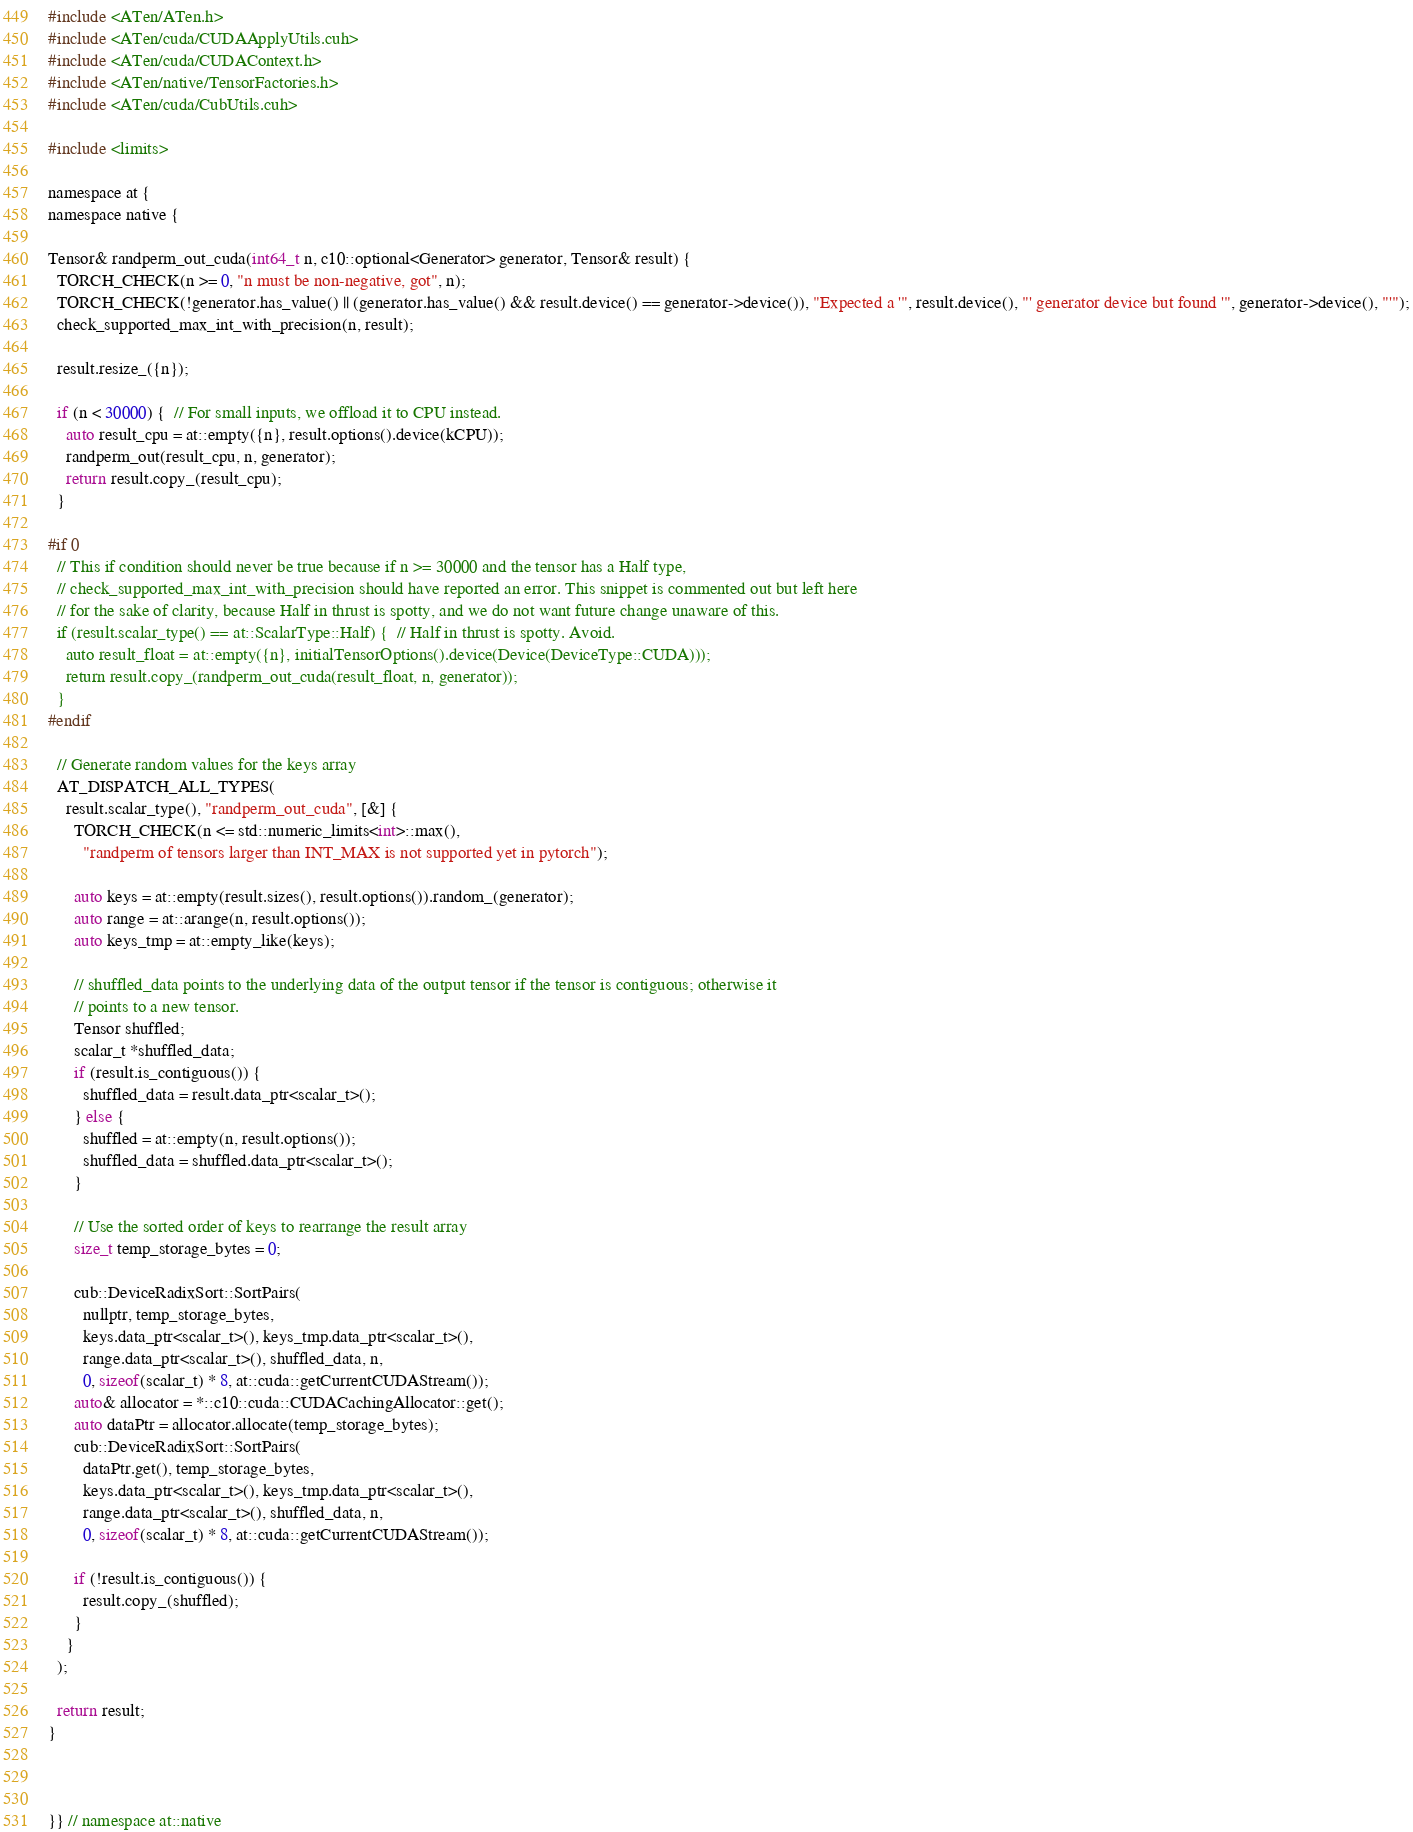<code> <loc_0><loc_0><loc_500><loc_500><_Cuda_>#include <ATen/ATen.h>
#include <ATen/cuda/CUDAApplyUtils.cuh>
#include <ATen/cuda/CUDAContext.h>
#include <ATen/native/TensorFactories.h>
#include <ATen/cuda/CubUtils.cuh>

#include <limits>

namespace at {
namespace native {

Tensor& randperm_out_cuda(int64_t n, c10::optional<Generator> generator, Tensor& result) {
  TORCH_CHECK(n >= 0, "n must be non-negative, got", n);
  TORCH_CHECK(!generator.has_value() || (generator.has_value() && result.device() == generator->device()), "Expected a '", result.device(), "' generator device but found '", generator->device(), "'");
  check_supported_max_int_with_precision(n, result);

  result.resize_({n});

  if (n < 30000) {  // For small inputs, we offload it to CPU instead.
    auto result_cpu = at::empty({n}, result.options().device(kCPU));
    randperm_out(result_cpu, n, generator);
    return result.copy_(result_cpu);
  }

#if 0
  // This if condition should never be true because if n >= 30000 and the tensor has a Half type,
  // check_supported_max_int_with_precision should have reported an error. This snippet is commented out but left here
  // for the sake of clarity, because Half in thrust is spotty, and we do not want future change unaware of this.
  if (result.scalar_type() == at::ScalarType::Half) {  // Half in thrust is spotty. Avoid.
    auto result_float = at::empty({n}, initialTensorOptions().device(Device(DeviceType::CUDA)));
    return result.copy_(randperm_out_cuda(result_float, n, generator));
  }
#endif

  // Generate random values for the keys array
  AT_DISPATCH_ALL_TYPES(
    result.scalar_type(), "randperm_out_cuda", [&] {
      TORCH_CHECK(n <= std::numeric_limits<int>::max(),
        "randperm of tensors larger than INT_MAX is not supported yet in pytorch");

      auto keys = at::empty(result.sizes(), result.options()).random_(generator);
      auto range = at::arange(n, result.options());
      auto keys_tmp = at::empty_like(keys);

      // shuffled_data points to the underlying data of the output tensor if the tensor is contiguous; otherwise it
      // points to a new tensor.
      Tensor shuffled;
      scalar_t *shuffled_data;
      if (result.is_contiguous()) {
        shuffled_data = result.data_ptr<scalar_t>();
      } else {
        shuffled = at::empty(n, result.options());
        shuffled_data = shuffled.data_ptr<scalar_t>();
      }

      // Use the sorted order of keys to rearrange the result array
      size_t temp_storage_bytes = 0;

      cub::DeviceRadixSort::SortPairs(
        nullptr, temp_storage_bytes,
        keys.data_ptr<scalar_t>(), keys_tmp.data_ptr<scalar_t>(),
        range.data_ptr<scalar_t>(), shuffled_data, n,
        0, sizeof(scalar_t) * 8, at::cuda::getCurrentCUDAStream());
      auto& allocator = *::c10::cuda::CUDACachingAllocator::get();
      auto dataPtr = allocator.allocate(temp_storage_bytes);
      cub::DeviceRadixSort::SortPairs(
        dataPtr.get(), temp_storage_bytes,
        keys.data_ptr<scalar_t>(), keys_tmp.data_ptr<scalar_t>(),
        range.data_ptr<scalar_t>(), shuffled_data, n,
        0, sizeof(scalar_t) * 8, at::cuda::getCurrentCUDAStream());

      if (!result.is_contiguous()) {
        result.copy_(shuffled);
      }
    }
  );

  return result;
}



}} // namespace at::native
</code> 